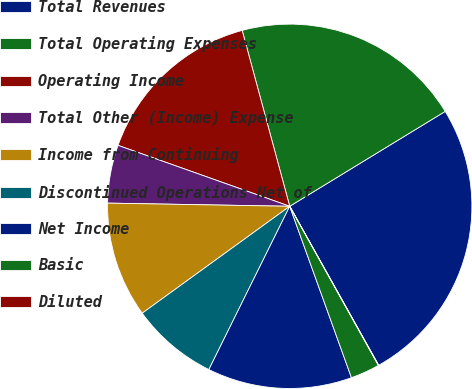<chart> <loc_0><loc_0><loc_500><loc_500><pie_chart><fcel>Total Revenues<fcel>Total Operating Expenses<fcel>Operating Income<fcel>Total Other (Income) Expense<fcel>Income from Continuing<fcel>Discontinued Operations Net of<fcel>Net Income<fcel>Basic<fcel>Diluted<nl><fcel>25.6%<fcel>20.48%<fcel>15.37%<fcel>5.15%<fcel>10.26%<fcel>7.7%<fcel>12.82%<fcel>2.59%<fcel>0.03%<nl></chart> 